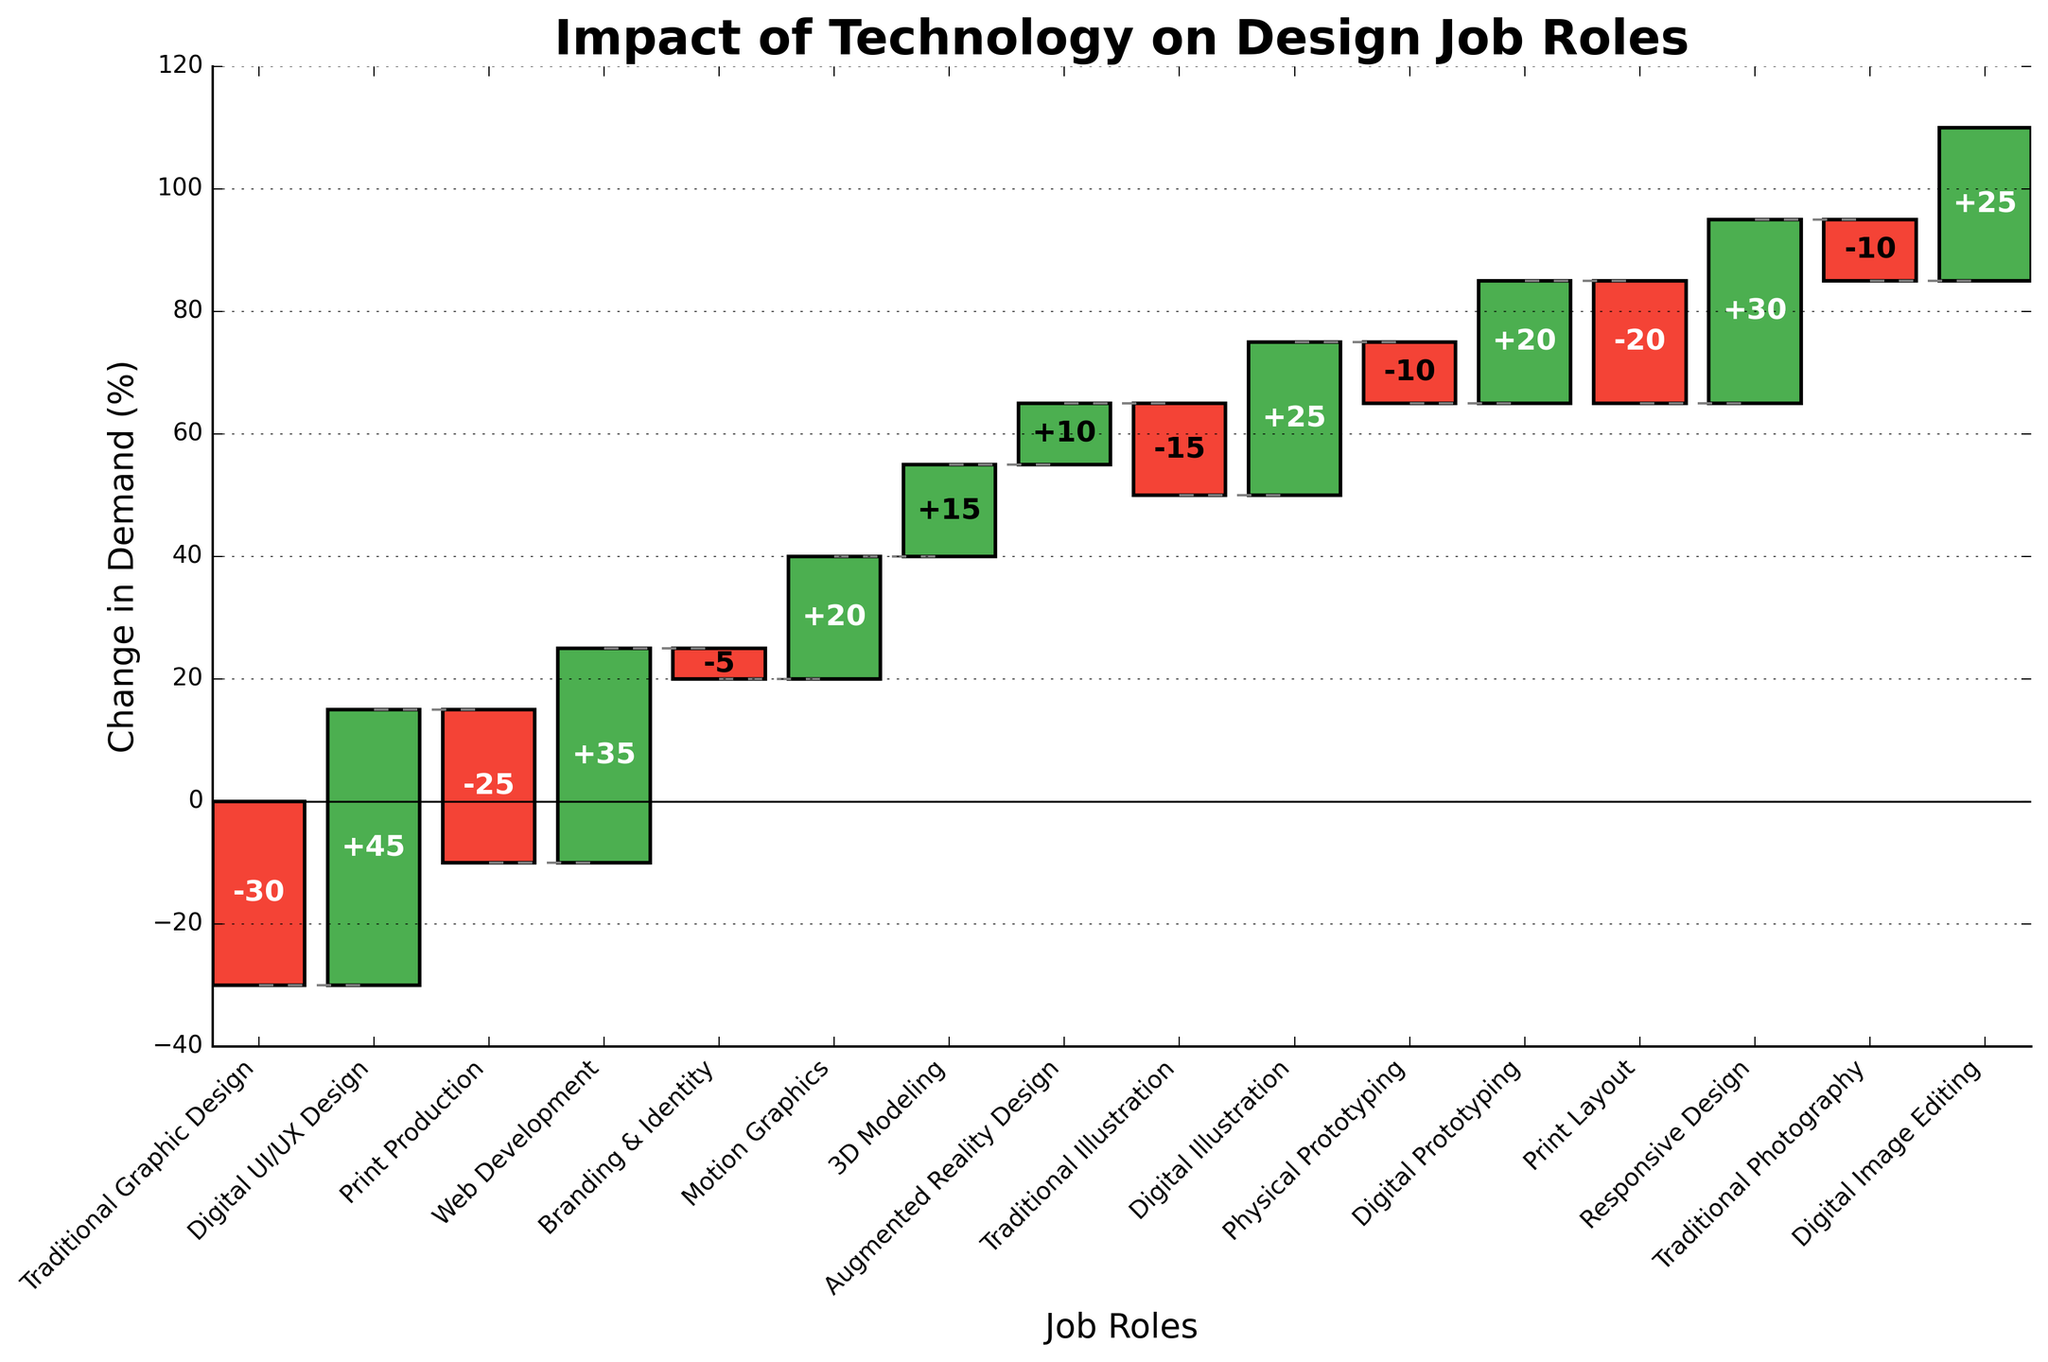What is the overall trend depicted in the chart? The overall trend shows a shift from traditional graphic design roles to digital design roles, with increases in demand for digital skills like UI/UX design, web development, and digital prototyping, while traditional roles like print production and traditional graphic design are in decline.
Answer: Shift from traditional to digital design roles Which job role experienced the highest increase in demand? By examining the height of the bars above the x-axis, the highest increase in demand is for Digital UI/UX Design at +45%.
Answer: Digital UI/UX Design Which job role experienced the most significant decrease in demand? By looking at the bars below the x-axis, Traditional Graphic Design experienced the most significant decrease at -30%.
Answer: Traditional Graphic Design Identify any job roles that remained relatively stable in demand, with changes less than ±5%. The job role Branding & Identity saw a slight decrease of -5%, indicating it's relatively stable compared to more drastic changes.
Answer: Branding & Identity Among the digital job roles, which one had the smallest increase in demand? The smallest increase for digital roles can be identified by the shortest positive bar, which is for Augmented Reality Design increasing by +10%.
Answer: Augmented Reality Design How many job roles had a positive change in demand? By counting the number of bars above the x-axis, there are 8 job roles with a positive change in demand.
Answer: 8 Which job roles are related to graphic design and how have they fared? Traditional Graphic Design and Digital Illustration are related to graphic design. Traditional Graphic Design decreased by -30%, while Digital Illustration increased by +25%.
Answer: Traditional Graphic Design decreased, Digital Illustration increased Calculate the net change based on the bar heights from traditional to digital skillsets, summing all positive and negative changes. Summing all positive changes (+45, +35, +20, +15, +10, +25, +20, +30, +25) gives +225. Summing all negative changes (-30, -25, -5, -15, -10, -20, -10) gives -115. Net change is 225 - 115 = +110.
Answer: +110 What is the cumulative change at the midpoint of the chart? (After the 8th job role) Cumulative changes are sequentially added per bar's value. At the 8th role, Augmented Reality Design (+10), cumulative from start: -30+45-25+35-5+20+15= 55, 55 +10 = 65.
Answer: +65 